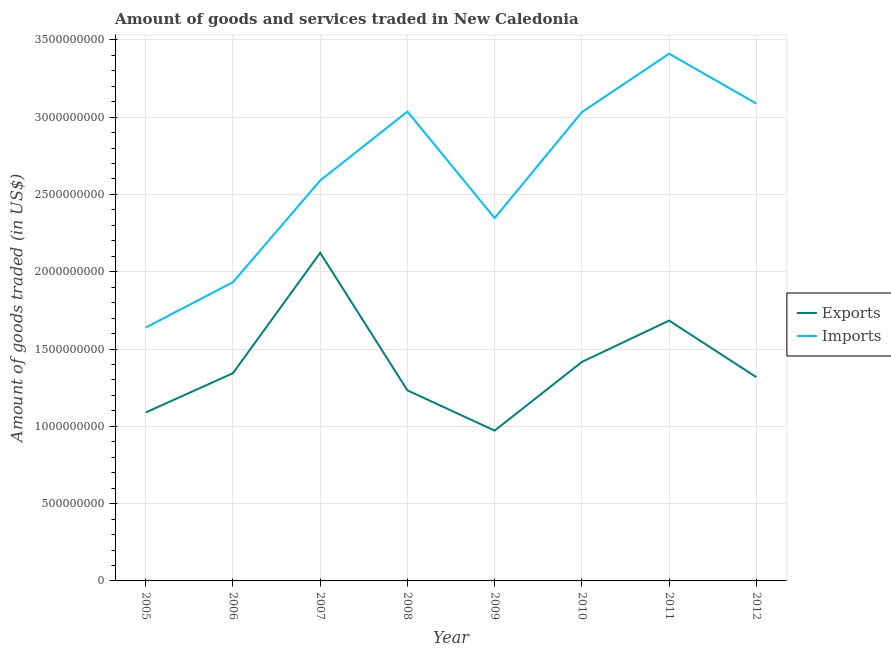Does the line corresponding to amount of goods exported intersect with the line corresponding to amount of goods imported?
Give a very brief answer. No. Is the number of lines equal to the number of legend labels?
Keep it short and to the point. Yes. What is the amount of goods imported in 2009?
Your answer should be compact. 2.35e+09. Across all years, what is the maximum amount of goods exported?
Provide a short and direct response. 2.12e+09. Across all years, what is the minimum amount of goods imported?
Offer a very short reply. 1.64e+09. In which year was the amount of goods exported maximum?
Ensure brevity in your answer.  2007. In which year was the amount of goods imported minimum?
Make the answer very short. 2005. What is the total amount of goods imported in the graph?
Offer a very short reply. 2.11e+1. What is the difference between the amount of goods imported in 2009 and that in 2011?
Offer a very short reply. -1.06e+09. What is the difference between the amount of goods imported in 2007 and the amount of goods exported in 2010?
Ensure brevity in your answer.  1.17e+09. What is the average amount of goods imported per year?
Give a very brief answer. 2.63e+09. In the year 2012, what is the difference between the amount of goods imported and amount of goods exported?
Offer a very short reply. 1.77e+09. What is the ratio of the amount of goods exported in 2008 to that in 2009?
Provide a succinct answer. 1.27. Is the amount of goods exported in 2006 less than that in 2010?
Your answer should be very brief. Yes. What is the difference between the highest and the second highest amount of goods imported?
Provide a short and direct response. 3.22e+08. What is the difference between the highest and the lowest amount of goods imported?
Offer a terse response. 1.77e+09. Is the sum of the amount of goods imported in 2007 and 2010 greater than the maximum amount of goods exported across all years?
Ensure brevity in your answer.  Yes. Does the amount of goods imported monotonically increase over the years?
Your response must be concise. No. What is the difference between two consecutive major ticks on the Y-axis?
Make the answer very short. 5.00e+08. Are the values on the major ticks of Y-axis written in scientific E-notation?
Your response must be concise. No. Does the graph contain grids?
Keep it short and to the point. Yes. Where does the legend appear in the graph?
Provide a short and direct response. Center right. How many legend labels are there?
Offer a terse response. 2. What is the title of the graph?
Your answer should be very brief. Amount of goods and services traded in New Caledonia. Does "Public credit registry" appear as one of the legend labels in the graph?
Offer a very short reply. No. What is the label or title of the Y-axis?
Your answer should be very brief. Amount of goods traded (in US$). What is the Amount of goods traded (in US$) in Exports in 2005?
Provide a succinct answer. 1.09e+09. What is the Amount of goods traded (in US$) in Imports in 2005?
Your response must be concise. 1.64e+09. What is the Amount of goods traded (in US$) in Exports in 2006?
Your answer should be very brief. 1.34e+09. What is the Amount of goods traded (in US$) in Imports in 2006?
Your answer should be very brief. 1.93e+09. What is the Amount of goods traded (in US$) of Exports in 2007?
Your answer should be compact. 2.12e+09. What is the Amount of goods traded (in US$) of Imports in 2007?
Offer a terse response. 2.59e+09. What is the Amount of goods traded (in US$) of Exports in 2008?
Keep it short and to the point. 1.23e+09. What is the Amount of goods traded (in US$) in Imports in 2008?
Provide a short and direct response. 3.04e+09. What is the Amount of goods traded (in US$) of Exports in 2009?
Your answer should be very brief. 9.72e+08. What is the Amount of goods traded (in US$) in Imports in 2009?
Provide a short and direct response. 2.35e+09. What is the Amount of goods traded (in US$) in Exports in 2010?
Provide a short and direct response. 1.42e+09. What is the Amount of goods traded (in US$) of Imports in 2010?
Keep it short and to the point. 3.03e+09. What is the Amount of goods traded (in US$) of Exports in 2011?
Make the answer very short. 1.68e+09. What is the Amount of goods traded (in US$) in Imports in 2011?
Make the answer very short. 3.41e+09. What is the Amount of goods traded (in US$) of Exports in 2012?
Keep it short and to the point. 1.32e+09. What is the Amount of goods traded (in US$) in Imports in 2012?
Your response must be concise. 3.09e+09. Across all years, what is the maximum Amount of goods traded (in US$) of Exports?
Your answer should be compact. 2.12e+09. Across all years, what is the maximum Amount of goods traded (in US$) of Imports?
Provide a short and direct response. 3.41e+09. Across all years, what is the minimum Amount of goods traded (in US$) in Exports?
Make the answer very short. 9.72e+08. Across all years, what is the minimum Amount of goods traded (in US$) in Imports?
Provide a succinct answer. 1.64e+09. What is the total Amount of goods traded (in US$) of Exports in the graph?
Your answer should be compact. 1.12e+1. What is the total Amount of goods traded (in US$) of Imports in the graph?
Provide a succinct answer. 2.11e+1. What is the difference between the Amount of goods traded (in US$) of Exports in 2005 and that in 2006?
Offer a very short reply. -2.54e+08. What is the difference between the Amount of goods traded (in US$) in Imports in 2005 and that in 2006?
Your answer should be very brief. -2.93e+08. What is the difference between the Amount of goods traded (in US$) of Exports in 2005 and that in 2007?
Provide a short and direct response. -1.03e+09. What is the difference between the Amount of goods traded (in US$) of Imports in 2005 and that in 2007?
Make the answer very short. -9.51e+08. What is the difference between the Amount of goods traded (in US$) in Exports in 2005 and that in 2008?
Make the answer very short. -1.43e+08. What is the difference between the Amount of goods traded (in US$) in Imports in 2005 and that in 2008?
Provide a short and direct response. -1.40e+09. What is the difference between the Amount of goods traded (in US$) in Exports in 2005 and that in 2009?
Your answer should be compact. 1.17e+08. What is the difference between the Amount of goods traded (in US$) in Imports in 2005 and that in 2009?
Your answer should be compact. -7.08e+08. What is the difference between the Amount of goods traded (in US$) of Exports in 2005 and that in 2010?
Provide a succinct answer. -3.27e+08. What is the difference between the Amount of goods traded (in US$) in Imports in 2005 and that in 2010?
Ensure brevity in your answer.  -1.39e+09. What is the difference between the Amount of goods traded (in US$) of Exports in 2005 and that in 2011?
Offer a terse response. -5.94e+08. What is the difference between the Amount of goods traded (in US$) of Imports in 2005 and that in 2011?
Provide a succinct answer. -1.77e+09. What is the difference between the Amount of goods traded (in US$) in Exports in 2005 and that in 2012?
Offer a very short reply. -2.28e+08. What is the difference between the Amount of goods traded (in US$) of Imports in 2005 and that in 2012?
Make the answer very short. -1.45e+09. What is the difference between the Amount of goods traded (in US$) in Exports in 2006 and that in 2007?
Offer a terse response. -7.79e+08. What is the difference between the Amount of goods traded (in US$) of Imports in 2006 and that in 2007?
Provide a short and direct response. -6.58e+08. What is the difference between the Amount of goods traded (in US$) in Exports in 2006 and that in 2008?
Offer a terse response. 1.11e+08. What is the difference between the Amount of goods traded (in US$) in Imports in 2006 and that in 2008?
Offer a very short reply. -1.10e+09. What is the difference between the Amount of goods traded (in US$) in Exports in 2006 and that in 2009?
Your response must be concise. 3.71e+08. What is the difference between the Amount of goods traded (in US$) of Imports in 2006 and that in 2009?
Keep it short and to the point. -4.15e+08. What is the difference between the Amount of goods traded (in US$) of Exports in 2006 and that in 2010?
Make the answer very short. -7.29e+07. What is the difference between the Amount of goods traded (in US$) of Imports in 2006 and that in 2010?
Make the answer very short. -1.10e+09. What is the difference between the Amount of goods traded (in US$) in Exports in 2006 and that in 2011?
Your answer should be compact. -3.40e+08. What is the difference between the Amount of goods traded (in US$) in Imports in 2006 and that in 2011?
Your answer should be compact. -1.48e+09. What is the difference between the Amount of goods traded (in US$) of Exports in 2006 and that in 2012?
Your response must be concise. 2.55e+07. What is the difference between the Amount of goods traded (in US$) in Imports in 2006 and that in 2012?
Give a very brief answer. -1.16e+09. What is the difference between the Amount of goods traded (in US$) of Exports in 2007 and that in 2008?
Your response must be concise. 8.90e+08. What is the difference between the Amount of goods traded (in US$) of Imports in 2007 and that in 2008?
Give a very brief answer. -4.46e+08. What is the difference between the Amount of goods traded (in US$) of Exports in 2007 and that in 2009?
Your answer should be compact. 1.15e+09. What is the difference between the Amount of goods traded (in US$) in Imports in 2007 and that in 2009?
Give a very brief answer. 2.43e+08. What is the difference between the Amount of goods traded (in US$) of Exports in 2007 and that in 2010?
Provide a short and direct response. 7.06e+08. What is the difference between the Amount of goods traded (in US$) in Imports in 2007 and that in 2010?
Provide a short and direct response. -4.42e+08. What is the difference between the Amount of goods traded (in US$) in Exports in 2007 and that in 2011?
Ensure brevity in your answer.  4.38e+08. What is the difference between the Amount of goods traded (in US$) in Imports in 2007 and that in 2011?
Ensure brevity in your answer.  -8.20e+08. What is the difference between the Amount of goods traded (in US$) of Exports in 2007 and that in 2012?
Your answer should be very brief. 8.04e+08. What is the difference between the Amount of goods traded (in US$) of Imports in 2007 and that in 2012?
Your response must be concise. -4.98e+08. What is the difference between the Amount of goods traded (in US$) in Exports in 2008 and that in 2009?
Keep it short and to the point. 2.60e+08. What is the difference between the Amount of goods traded (in US$) in Imports in 2008 and that in 2009?
Make the answer very short. 6.89e+08. What is the difference between the Amount of goods traded (in US$) in Exports in 2008 and that in 2010?
Your answer should be compact. -1.84e+08. What is the difference between the Amount of goods traded (in US$) in Imports in 2008 and that in 2010?
Offer a terse response. 3.46e+06. What is the difference between the Amount of goods traded (in US$) in Exports in 2008 and that in 2011?
Your answer should be very brief. -4.51e+08. What is the difference between the Amount of goods traded (in US$) of Imports in 2008 and that in 2011?
Your answer should be compact. -3.74e+08. What is the difference between the Amount of goods traded (in US$) of Exports in 2008 and that in 2012?
Provide a succinct answer. -8.53e+07. What is the difference between the Amount of goods traded (in US$) of Imports in 2008 and that in 2012?
Ensure brevity in your answer.  -5.20e+07. What is the difference between the Amount of goods traded (in US$) of Exports in 2009 and that in 2010?
Provide a succinct answer. -4.44e+08. What is the difference between the Amount of goods traded (in US$) in Imports in 2009 and that in 2010?
Your response must be concise. -6.85e+08. What is the difference between the Amount of goods traded (in US$) in Exports in 2009 and that in 2011?
Make the answer very short. -7.12e+08. What is the difference between the Amount of goods traded (in US$) in Imports in 2009 and that in 2011?
Your answer should be compact. -1.06e+09. What is the difference between the Amount of goods traded (in US$) in Exports in 2009 and that in 2012?
Your response must be concise. -3.46e+08. What is the difference between the Amount of goods traded (in US$) of Imports in 2009 and that in 2012?
Provide a short and direct response. -7.41e+08. What is the difference between the Amount of goods traded (in US$) of Exports in 2010 and that in 2011?
Keep it short and to the point. -2.67e+08. What is the difference between the Amount of goods traded (in US$) of Imports in 2010 and that in 2011?
Ensure brevity in your answer.  -3.78e+08. What is the difference between the Amount of goods traded (in US$) of Exports in 2010 and that in 2012?
Keep it short and to the point. 9.84e+07. What is the difference between the Amount of goods traded (in US$) in Imports in 2010 and that in 2012?
Ensure brevity in your answer.  -5.54e+07. What is the difference between the Amount of goods traded (in US$) of Exports in 2011 and that in 2012?
Offer a very short reply. 3.66e+08. What is the difference between the Amount of goods traded (in US$) in Imports in 2011 and that in 2012?
Give a very brief answer. 3.22e+08. What is the difference between the Amount of goods traded (in US$) of Exports in 2005 and the Amount of goods traded (in US$) of Imports in 2006?
Your response must be concise. -8.43e+08. What is the difference between the Amount of goods traded (in US$) in Exports in 2005 and the Amount of goods traded (in US$) in Imports in 2007?
Provide a succinct answer. -1.50e+09. What is the difference between the Amount of goods traded (in US$) in Exports in 2005 and the Amount of goods traded (in US$) in Imports in 2008?
Provide a succinct answer. -1.95e+09. What is the difference between the Amount of goods traded (in US$) in Exports in 2005 and the Amount of goods traded (in US$) in Imports in 2009?
Offer a terse response. -1.26e+09. What is the difference between the Amount of goods traded (in US$) in Exports in 2005 and the Amount of goods traded (in US$) in Imports in 2010?
Give a very brief answer. -1.94e+09. What is the difference between the Amount of goods traded (in US$) of Exports in 2005 and the Amount of goods traded (in US$) of Imports in 2011?
Provide a short and direct response. -2.32e+09. What is the difference between the Amount of goods traded (in US$) of Exports in 2005 and the Amount of goods traded (in US$) of Imports in 2012?
Offer a terse response. -2.00e+09. What is the difference between the Amount of goods traded (in US$) of Exports in 2006 and the Amount of goods traded (in US$) of Imports in 2007?
Give a very brief answer. -1.25e+09. What is the difference between the Amount of goods traded (in US$) of Exports in 2006 and the Amount of goods traded (in US$) of Imports in 2008?
Ensure brevity in your answer.  -1.69e+09. What is the difference between the Amount of goods traded (in US$) of Exports in 2006 and the Amount of goods traded (in US$) of Imports in 2009?
Offer a very short reply. -1.00e+09. What is the difference between the Amount of goods traded (in US$) in Exports in 2006 and the Amount of goods traded (in US$) in Imports in 2010?
Keep it short and to the point. -1.69e+09. What is the difference between the Amount of goods traded (in US$) in Exports in 2006 and the Amount of goods traded (in US$) in Imports in 2011?
Keep it short and to the point. -2.07e+09. What is the difference between the Amount of goods traded (in US$) in Exports in 2006 and the Amount of goods traded (in US$) in Imports in 2012?
Provide a succinct answer. -1.74e+09. What is the difference between the Amount of goods traded (in US$) of Exports in 2007 and the Amount of goods traded (in US$) of Imports in 2008?
Provide a succinct answer. -9.13e+08. What is the difference between the Amount of goods traded (in US$) of Exports in 2007 and the Amount of goods traded (in US$) of Imports in 2009?
Give a very brief answer. -2.25e+08. What is the difference between the Amount of goods traded (in US$) in Exports in 2007 and the Amount of goods traded (in US$) in Imports in 2010?
Make the answer very short. -9.10e+08. What is the difference between the Amount of goods traded (in US$) of Exports in 2007 and the Amount of goods traded (in US$) of Imports in 2011?
Make the answer very short. -1.29e+09. What is the difference between the Amount of goods traded (in US$) in Exports in 2007 and the Amount of goods traded (in US$) in Imports in 2012?
Give a very brief answer. -9.65e+08. What is the difference between the Amount of goods traded (in US$) of Exports in 2008 and the Amount of goods traded (in US$) of Imports in 2009?
Your response must be concise. -1.11e+09. What is the difference between the Amount of goods traded (in US$) of Exports in 2008 and the Amount of goods traded (in US$) of Imports in 2010?
Make the answer very short. -1.80e+09. What is the difference between the Amount of goods traded (in US$) of Exports in 2008 and the Amount of goods traded (in US$) of Imports in 2011?
Offer a very short reply. -2.18e+09. What is the difference between the Amount of goods traded (in US$) in Exports in 2008 and the Amount of goods traded (in US$) in Imports in 2012?
Provide a short and direct response. -1.86e+09. What is the difference between the Amount of goods traded (in US$) of Exports in 2009 and the Amount of goods traded (in US$) of Imports in 2010?
Provide a succinct answer. -2.06e+09. What is the difference between the Amount of goods traded (in US$) in Exports in 2009 and the Amount of goods traded (in US$) in Imports in 2011?
Your response must be concise. -2.44e+09. What is the difference between the Amount of goods traded (in US$) in Exports in 2009 and the Amount of goods traded (in US$) in Imports in 2012?
Offer a very short reply. -2.12e+09. What is the difference between the Amount of goods traded (in US$) in Exports in 2010 and the Amount of goods traded (in US$) in Imports in 2011?
Provide a succinct answer. -1.99e+09. What is the difference between the Amount of goods traded (in US$) in Exports in 2010 and the Amount of goods traded (in US$) in Imports in 2012?
Provide a succinct answer. -1.67e+09. What is the difference between the Amount of goods traded (in US$) in Exports in 2011 and the Amount of goods traded (in US$) in Imports in 2012?
Give a very brief answer. -1.40e+09. What is the average Amount of goods traded (in US$) of Exports per year?
Provide a short and direct response. 1.40e+09. What is the average Amount of goods traded (in US$) in Imports per year?
Ensure brevity in your answer.  2.63e+09. In the year 2005, what is the difference between the Amount of goods traded (in US$) in Exports and Amount of goods traded (in US$) in Imports?
Give a very brief answer. -5.49e+08. In the year 2006, what is the difference between the Amount of goods traded (in US$) of Exports and Amount of goods traded (in US$) of Imports?
Provide a short and direct response. -5.89e+08. In the year 2007, what is the difference between the Amount of goods traded (in US$) in Exports and Amount of goods traded (in US$) in Imports?
Provide a succinct answer. -4.68e+08. In the year 2008, what is the difference between the Amount of goods traded (in US$) of Exports and Amount of goods traded (in US$) of Imports?
Your answer should be very brief. -1.80e+09. In the year 2009, what is the difference between the Amount of goods traded (in US$) in Exports and Amount of goods traded (in US$) in Imports?
Make the answer very short. -1.37e+09. In the year 2010, what is the difference between the Amount of goods traded (in US$) in Exports and Amount of goods traded (in US$) in Imports?
Give a very brief answer. -1.62e+09. In the year 2011, what is the difference between the Amount of goods traded (in US$) in Exports and Amount of goods traded (in US$) in Imports?
Make the answer very short. -1.73e+09. In the year 2012, what is the difference between the Amount of goods traded (in US$) in Exports and Amount of goods traded (in US$) in Imports?
Give a very brief answer. -1.77e+09. What is the ratio of the Amount of goods traded (in US$) of Exports in 2005 to that in 2006?
Offer a very short reply. 0.81. What is the ratio of the Amount of goods traded (in US$) of Imports in 2005 to that in 2006?
Provide a short and direct response. 0.85. What is the ratio of the Amount of goods traded (in US$) of Exports in 2005 to that in 2007?
Provide a short and direct response. 0.51. What is the ratio of the Amount of goods traded (in US$) of Imports in 2005 to that in 2007?
Your answer should be very brief. 0.63. What is the ratio of the Amount of goods traded (in US$) of Exports in 2005 to that in 2008?
Make the answer very short. 0.88. What is the ratio of the Amount of goods traded (in US$) in Imports in 2005 to that in 2008?
Make the answer very short. 0.54. What is the ratio of the Amount of goods traded (in US$) of Exports in 2005 to that in 2009?
Your answer should be compact. 1.12. What is the ratio of the Amount of goods traded (in US$) of Imports in 2005 to that in 2009?
Offer a very short reply. 0.7. What is the ratio of the Amount of goods traded (in US$) of Exports in 2005 to that in 2010?
Ensure brevity in your answer.  0.77. What is the ratio of the Amount of goods traded (in US$) of Imports in 2005 to that in 2010?
Provide a succinct answer. 0.54. What is the ratio of the Amount of goods traded (in US$) of Exports in 2005 to that in 2011?
Your response must be concise. 0.65. What is the ratio of the Amount of goods traded (in US$) in Imports in 2005 to that in 2011?
Your answer should be very brief. 0.48. What is the ratio of the Amount of goods traded (in US$) of Exports in 2005 to that in 2012?
Make the answer very short. 0.83. What is the ratio of the Amount of goods traded (in US$) in Imports in 2005 to that in 2012?
Give a very brief answer. 0.53. What is the ratio of the Amount of goods traded (in US$) in Exports in 2006 to that in 2007?
Keep it short and to the point. 0.63. What is the ratio of the Amount of goods traded (in US$) in Imports in 2006 to that in 2007?
Your answer should be very brief. 0.75. What is the ratio of the Amount of goods traded (in US$) of Exports in 2006 to that in 2008?
Your answer should be very brief. 1.09. What is the ratio of the Amount of goods traded (in US$) in Imports in 2006 to that in 2008?
Provide a succinct answer. 0.64. What is the ratio of the Amount of goods traded (in US$) of Exports in 2006 to that in 2009?
Ensure brevity in your answer.  1.38. What is the ratio of the Amount of goods traded (in US$) in Imports in 2006 to that in 2009?
Make the answer very short. 0.82. What is the ratio of the Amount of goods traded (in US$) in Exports in 2006 to that in 2010?
Offer a very short reply. 0.95. What is the ratio of the Amount of goods traded (in US$) of Imports in 2006 to that in 2010?
Ensure brevity in your answer.  0.64. What is the ratio of the Amount of goods traded (in US$) of Exports in 2006 to that in 2011?
Offer a terse response. 0.8. What is the ratio of the Amount of goods traded (in US$) in Imports in 2006 to that in 2011?
Your answer should be very brief. 0.57. What is the ratio of the Amount of goods traded (in US$) in Exports in 2006 to that in 2012?
Give a very brief answer. 1.02. What is the ratio of the Amount of goods traded (in US$) in Imports in 2006 to that in 2012?
Offer a very short reply. 0.63. What is the ratio of the Amount of goods traded (in US$) in Exports in 2007 to that in 2008?
Ensure brevity in your answer.  1.72. What is the ratio of the Amount of goods traded (in US$) of Imports in 2007 to that in 2008?
Offer a very short reply. 0.85. What is the ratio of the Amount of goods traded (in US$) of Exports in 2007 to that in 2009?
Your response must be concise. 2.18. What is the ratio of the Amount of goods traded (in US$) of Imports in 2007 to that in 2009?
Provide a short and direct response. 1.1. What is the ratio of the Amount of goods traded (in US$) of Exports in 2007 to that in 2010?
Your answer should be very brief. 1.5. What is the ratio of the Amount of goods traded (in US$) of Imports in 2007 to that in 2010?
Make the answer very short. 0.85. What is the ratio of the Amount of goods traded (in US$) of Exports in 2007 to that in 2011?
Your answer should be compact. 1.26. What is the ratio of the Amount of goods traded (in US$) of Imports in 2007 to that in 2011?
Provide a succinct answer. 0.76. What is the ratio of the Amount of goods traded (in US$) in Exports in 2007 to that in 2012?
Keep it short and to the point. 1.61. What is the ratio of the Amount of goods traded (in US$) of Imports in 2007 to that in 2012?
Your answer should be very brief. 0.84. What is the ratio of the Amount of goods traded (in US$) of Exports in 2008 to that in 2009?
Provide a succinct answer. 1.27. What is the ratio of the Amount of goods traded (in US$) of Imports in 2008 to that in 2009?
Give a very brief answer. 1.29. What is the ratio of the Amount of goods traded (in US$) in Exports in 2008 to that in 2010?
Offer a terse response. 0.87. What is the ratio of the Amount of goods traded (in US$) in Imports in 2008 to that in 2010?
Your answer should be compact. 1. What is the ratio of the Amount of goods traded (in US$) in Exports in 2008 to that in 2011?
Offer a terse response. 0.73. What is the ratio of the Amount of goods traded (in US$) of Imports in 2008 to that in 2011?
Ensure brevity in your answer.  0.89. What is the ratio of the Amount of goods traded (in US$) in Exports in 2008 to that in 2012?
Your answer should be compact. 0.94. What is the ratio of the Amount of goods traded (in US$) in Imports in 2008 to that in 2012?
Offer a very short reply. 0.98. What is the ratio of the Amount of goods traded (in US$) of Exports in 2009 to that in 2010?
Give a very brief answer. 0.69. What is the ratio of the Amount of goods traded (in US$) of Imports in 2009 to that in 2010?
Provide a succinct answer. 0.77. What is the ratio of the Amount of goods traded (in US$) in Exports in 2009 to that in 2011?
Give a very brief answer. 0.58. What is the ratio of the Amount of goods traded (in US$) of Imports in 2009 to that in 2011?
Provide a succinct answer. 0.69. What is the ratio of the Amount of goods traded (in US$) of Exports in 2009 to that in 2012?
Give a very brief answer. 0.74. What is the ratio of the Amount of goods traded (in US$) of Imports in 2009 to that in 2012?
Keep it short and to the point. 0.76. What is the ratio of the Amount of goods traded (in US$) in Exports in 2010 to that in 2011?
Make the answer very short. 0.84. What is the ratio of the Amount of goods traded (in US$) in Imports in 2010 to that in 2011?
Your answer should be compact. 0.89. What is the ratio of the Amount of goods traded (in US$) in Exports in 2010 to that in 2012?
Provide a succinct answer. 1.07. What is the ratio of the Amount of goods traded (in US$) in Imports in 2010 to that in 2012?
Offer a very short reply. 0.98. What is the ratio of the Amount of goods traded (in US$) in Exports in 2011 to that in 2012?
Make the answer very short. 1.28. What is the ratio of the Amount of goods traded (in US$) of Imports in 2011 to that in 2012?
Make the answer very short. 1.1. What is the difference between the highest and the second highest Amount of goods traded (in US$) of Exports?
Provide a succinct answer. 4.38e+08. What is the difference between the highest and the second highest Amount of goods traded (in US$) of Imports?
Provide a short and direct response. 3.22e+08. What is the difference between the highest and the lowest Amount of goods traded (in US$) in Exports?
Provide a succinct answer. 1.15e+09. What is the difference between the highest and the lowest Amount of goods traded (in US$) of Imports?
Make the answer very short. 1.77e+09. 